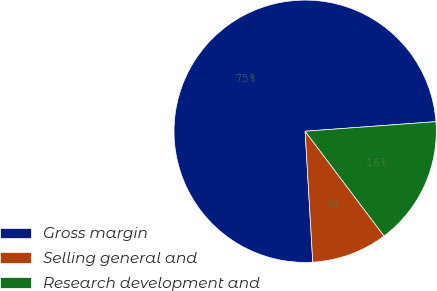<chart> <loc_0><loc_0><loc_500><loc_500><pie_chart><fcel>Gross margin<fcel>Selling general and<fcel>Research development and<nl><fcel>74.77%<fcel>9.35%<fcel>15.89%<nl></chart> 